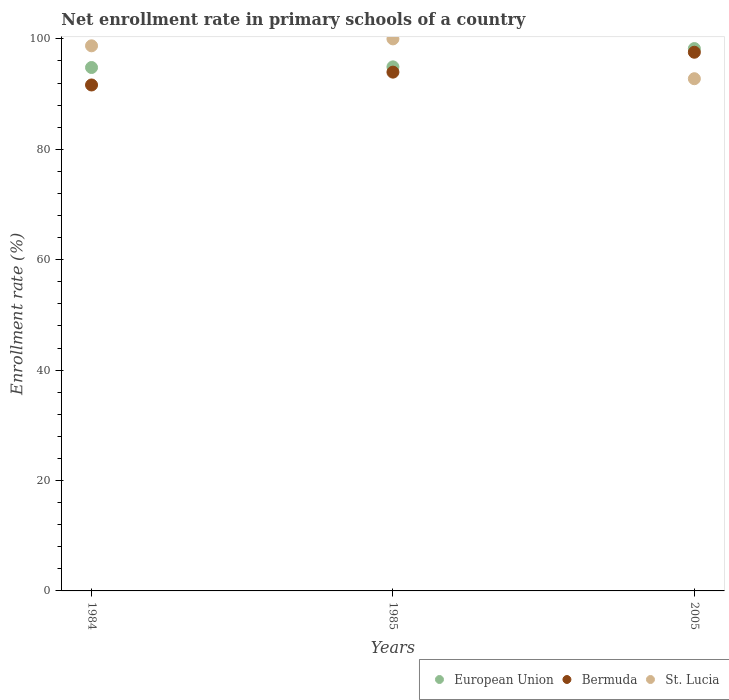What is the enrollment rate in primary schools in European Union in 2005?
Provide a succinct answer. 98.24. Across all years, what is the maximum enrollment rate in primary schools in Bermuda?
Make the answer very short. 97.58. Across all years, what is the minimum enrollment rate in primary schools in St. Lucia?
Offer a very short reply. 92.78. In which year was the enrollment rate in primary schools in St. Lucia maximum?
Provide a succinct answer. 1985. What is the total enrollment rate in primary schools in St. Lucia in the graph?
Provide a succinct answer. 291.53. What is the difference between the enrollment rate in primary schools in Bermuda in 1984 and that in 1985?
Offer a very short reply. -2.33. What is the difference between the enrollment rate in primary schools in European Union in 1984 and the enrollment rate in primary schools in St. Lucia in 2005?
Keep it short and to the point. 2.03. What is the average enrollment rate in primary schools in European Union per year?
Offer a very short reply. 96. In the year 1984, what is the difference between the enrollment rate in primary schools in Bermuda and enrollment rate in primary schools in European Union?
Your answer should be very brief. -3.16. What is the ratio of the enrollment rate in primary schools in Bermuda in 1984 to that in 2005?
Offer a terse response. 0.94. Is the enrollment rate in primary schools in Bermuda in 1984 less than that in 2005?
Your response must be concise. Yes. What is the difference between the highest and the second highest enrollment rate in primary schools in European Union?
Ensure brevity in your answer.  3.31. What is the difference between the highest and the lowest enrollment rate in primary schools in St. Lucia?
Your response must be concise. 7.22. In how many years, is the enrollment rate in primary schools in St. Lucia greater than the average enrollment rate in primary schools in St. Lucia taken over all years?
Make the answer very short. 2. Is the sum of the enrollment rate in primary schools in Bermuda in 1984 and 1985 greater than the maximum enrollment rate in primary schools in St. Lucia across all years?
Offer a terse response. Yes. Is it the case that in every year, the sum of the enrollment rate in primary schools in European Union and enrollment rate in primary schools in St. Lucia  is greater than the enrollment rate in primary schools in Bermuda?
Your answer should be compact. Yes. Is the enrollment rate in primary schools in European Union strictly greater than the enrollment rate in primary schools in Bermuda over the years?
Give a very brief answer. Yes. How many years are there in the graph?
Provide a short and direct response. 3. What is the difference between two consecutive major ticks on the Y-axis?
Provide a short and direct response. 20. Does the graph contain grids?
Keep it short and to the point. No. Where does the legend appear in the graph?
Offer a very short reply. Bottom right. How many legend labels are there?
Give a very brief answer. 3. How are the legend labels stacked?
Offer a terse response. Horizontal. What is the title of the graph?
Offer a terse response. Net enrollment rate in primary schools of a country. Does "Kosovo" appear as one of the legend labels in the graph?
Offer a terse response. No. What is the label or title of the X-axis?
Provide a succinct answer. Years. What is the label or title of the Y-axis?
Your response must be concise. Enrollment rate (%). What is the Enrollment rate (%) of European Union in 1984?
Make the answer very short. 94.81. What is the Enrollment rate (%) in Bermuda in 1984?
Keep it short and to the point. 91.65. What is the Enrollment rate (%) in St. Lucia in 1984?
Keep it short and to the point. 98.74. What is the Enrollment rate (%) in European Union in 1985?
Offer a terse response. 94.93. What is the Enrollment rate (%) of Bermuda in 1985?
Give a very brief answer. 93.98. What is the Enrollment rate (%) of European Union in 2005?
Provide a short and direct response. 98.24. What is the Enrollment rate (%) in Bermuda in 2005?
Give a very brief answer. 97.58. What is the Enrollment rate (%) in St. Lucia in 2005?
Ensure brevity in your answer.  92.78. Across all years, what is the maximum Enrollment rate (%) in European Union?
Make the answer very short. 98.24. Across all years, what is the maximum Enrollment rate (%) of Bermuda?
Offer a terse response. 97.58. Across all years, what is the minimum Enrollment rate (%) of European Union?
Keep it short and to the point. 94.81. Across all years, what is the minimum Enrollment rate (%) in Bermuda?
Provide a short and direct response. 91.65. Across all years, what is the minimum Enrollment rate (%) of St. Lucia?
Your response must be concise. 92.78. What is the total Enrollment rate (%) in European Union in the graph?
Your answer should be compact. 287.99. What is the total Enrollment rate (%) of Bermuda in the graph?
Give a very brief answer. 283.2. What is the total Enrollment rate (%) in St. Lucia in the graph?
Make the answer very short. 291.53. What is the difference between the Enrollment rate (%) of European Union in 1984 and that in 1985?
Offer a terse response. -0.12. What is the difference between the Enrollment rate (%) in Bermuda in 1984 and that in 1985?
Offer a very short reply. -2.33. What is the difference between the Enrollment rate (%) of St. Lucia in 1984 and that in 1985?
Provide a succinct answer. -1.26. What is the difference between the Enrollment rate (%) in European Union in 1984 and that in 2005?
Keep it short and to the point. -3.43. What is the difference between the Enrollment rate (%) of Bermuda in 1984 and that in 2005?
Your response must be concise. -5.93. What is the difference between the Enrollment rate (%) of St. Lucia in 1984 and that in 2005?
Give a very brief answer. 5.96. What is the difference between the Enrollment rate (%) in European Union in 1985 and that in 2005?
Give a very brief answer. -3.31. What is the difference between the Enrollment rate (%) of Bermuda in 1985 and that in 2005?
Your answer should be compact. -3.61. What is the difference between the Enrollment rate (%) of St. Lucia in 1985 and that in 2005?
Your answer should be very brief. 7.22. What is the difference between the Enrollment rate (%) of European Union in 1984 and the Enrollment rate (%) of Bermuda in 1985?
Ensure brevity in your answer.  0.84. What is the difference between the Enrollment rate (%) in European Union in 1984 and the Enrollment rate (%) in St. Lucia in 1985?
Ensure brevity in your answer.  -5.19. What is the difference between the Enrollment rate (%) in Bermuda in 1984 and the Enrollment rate (%) in St. Lucia in 1985?
Provide a short and direct response. -8.35. What is the difference between the Enrollment rate (%) of European Union in 1984 and the Enrollment rate (%) of Bermuda in 2005?
Provide a succinct answer. -2.77. What is the difference between the Enrollment rate (%) of European Union in 1984 and the Enrollment rate (%) of St. Lucia in 2005?
Ensure brevity in your answer.  2.03. What is the difference between the Enrollment rate (%) of Bermuda in 1984 and the Enrollment rate (%) of St. Lucia in 2005?
Offer a very short reply. -1.14. What is the difference between the Enrollment rate (%) in European Union in 1985 and the Enrollment rate (%) in Bermuda in 2005?
Give a very brief answer. -2.65. What is the difference between the Enrollment rate (%) of European Union in 1985 and the Enrollment rate (%) of St. Lucia in 2005?
Ensure brevity in your answer.  2.15. What is the difference between the Enrollment rate (%) in Bermuda in 1985 and the Enrollment rate (%) in St. Lucia in 2005?
Provide a short and direct response. 1.19. What is the average Enrollment rate (%) in European Union per year?
Your response must be concise. 96. What is the average Enrollment rate (%) of Bermuda per year?
Provide a succinct answer. 94.4. What is the average Enrollment rate (%) in St. Lucia per year?
Provide a succinct answer. 97.18. In the year 1984, what is the difference between the Enrollment rate (%) of European Union and Enrollment rate (%) of Bermuda?
Keep it short and to the point. 3.16. In the year 1984, what is the difference between the Enrollment rate (%) in European Union and Enrollment rate (%) in St. Lucia?
Give a very brief answer. -3.93. In the year 1984, what is the difference between the Enrollment rate (%) of Bermuda and Enrollment rate (%) of St. Lucia?
Offer a very short reply. -7.09. In the year 1985, what is the difference between the Enrollment rate (%) of European Union and Enrollment rate (%) of Bermuda?
Ensure brevity in your answer.  0.96. In the year 1985, what is the difference between the Enrollment rate (%) of European Union and Enrollment rate (%) of St. Lucia?
Your answer should be compact. -5.07. In the year 1985, what is the difference between the Enrollment rate (%) in Bermuda and Enrollment rate (%) in St. Lucia?
Your response must be concise. -6.02. In the year 2005, what is the difference between the Enrollment rate (%) of European Union and Enrollment rate (%) of Bermuda?
Keep it short and to the point. 0.66. In the year 2005, what is the difference between the Enrollment rate (%) in European Union and Enrollment rate (%) in St. Lucia?
Your response must be concise. 5.46. In the year 2005, what is the difference between the Enrollment rate (%) of Bermuda and Enrollment rate (%) of St. Lucia?
Your answer should be compact. 4.8. What is the ratio of the Enrollment rate (%) of European Union in 1984 to that in 1985?
Give a very brief answer. 1. What is the ratio of the Enrollment rate (%) of Bermuda in 1984 to that in 1985?
Make the answer very short. 0.98. What is the ratio of the Enrollment rate (%) in St. Lucia in 1984 to that in 1985?
Give a very brief answer. 0.99. What is the ratio of the Enrollment rate (%) of European Union in 1984 to that in 2005?
Offer a very short reply. 0.97. What is the ratio of the Enrollment rate (%) of Bermuda in 1984 to that in 2005?
Provide a short and direct response. 0.94. What is the ratio of the Enrollment rate (%) in St. Lucia in 1984 to that in 2005?
Your answer should be compact. 1.06. What is the ratio of the Enrollment rate (%) of European Union in 1985 to that in 2005?
Your answer should be very brief. 0.97. What is the ratio of the Enrollment rate (%) of Bermuda in 1985 to that in 2005?
Offer a terse response. 0.96. What is the ratio of the Enrollment rate (%) of St. Lucia in 1985 to that in 2005?
Provide a succinct answer. 1.08. What is the difference between the highest and the second highest Enrollment rate (%) of European Union?
Ensure brevity in your answer.  3.31. What is the difference between the highest and the second highest Enrollment rate (%) of Bermuda?
Give a very brief answer. 3.61. What is the difference between the highest and the second highest Enrollment rate (%) of St. Lucia?
Your answer should be very brief. 1.26. What is the difference between the highest and the lowest Enrollment rate (%) of European Union?
Keep it short and to the point. 3.43. What is the difference between the highest and the lowest Enrollment rate (%) in Bermuda?
Your answer should be compact. 5.93. What is the difference between the highest and the lowest Enrollment rate (%) of St. Lucia?
Provide a short and direct response. 7.22. 